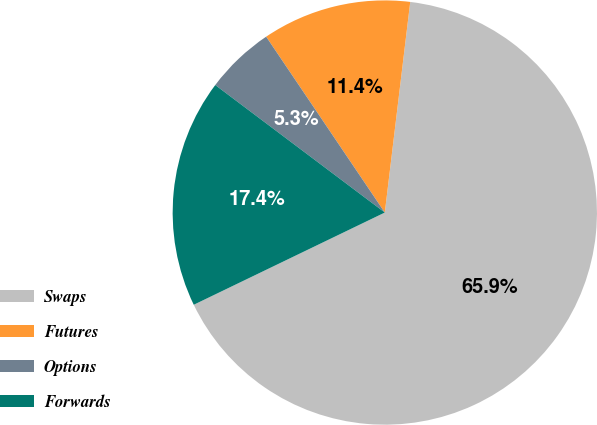Convert chart. <chart><loc_0><loc_0><loc_500><loc_500><pie_chart><fcel>Swaps<fcel>Futures<fcel>Options<fcel>Forwards<nl><fcel>65.93%<fcel>11.36%<fcel>5.29%<fcel>17.42%<nl></chart> 